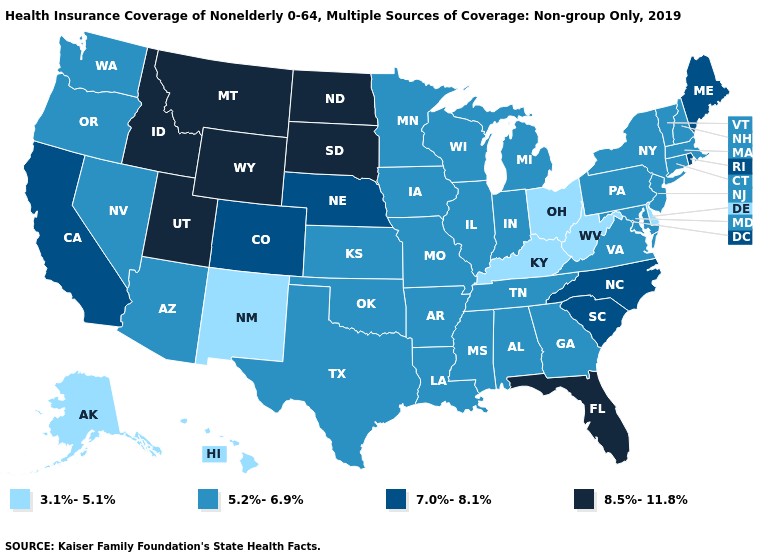Does New Hampshire have a lower value than Georgia?
Be succinct. No. Name the states that have a value in the range 8.5%-11.8%?
Be succinct. Florida, Idaho, Montana, North Dakota, South Dakota, Utah, Wyoming. Does New York have the same value as Minnesota?
Quick response, please. Yes. Name the states that have a value in the range 7.0%-8.1%?
Quick response, please. California, Colorado, Maine, Nebraska, North Carolina, Rhode Island, South Carolina. Which states have the lowest value in the USA?
Short answer required. Alaska, Delaware, Hawaii, Kentucky, New Mexico, Ohio, West Virginia. Does the map have missing data?
Be succinct. No. Name the states that have a value in the range 5.2%-6.9%?
Keep it brief. Alabama, Arizona, Arkansas, Connecticut, Georgia, Illinois, Indiana, Iowa, Kansas, Louisiana, Maryland, Massachusetts, Michigan, Minnesota, Mississippi, Missouri, Nevada, New Hampshire, New Jersey, New York, Oklahoma, Oregon, Pennsylvania, Tennessee, Texas, Vermont, Virginia, Washington, Wisconsin. What is the highest value in states that border Michigan?
Answer briefly. 5.2%-6.9%. What is the value of Arkansas?
Give a very brief answer. 5.2%-6.9%. What is the highest value in states that border California?
Write a very short answer. 5.2%-6.9%. What is the value of Idaho?
Give a very brief answer. 8.5%-11.8%. Which states have the lowest value in the USA?
Give a very brief answer. Alaska, Delaware, Hawaii, Kentucky, New Mexico, Ohio, West Virginia. What is the lowest value in states that border Nevada?
Keep it brief. 5.2%-6.9%. Is the legend a continuous bar?
Short answer required. No. Which states have the lowest value in the MidWest?
Concise answer only. Ohio. 